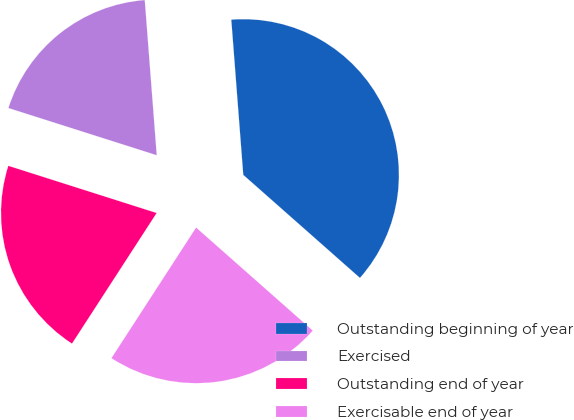Convert chart to OTSL. <chart><loc_0><loc_0><loc_500><loc_500><pie_chart><fcel>Outstanding beginning of year<fcel>Exercised<fcel>Outstanding end of year<fcel>Exercisable end of year<nl><fcel>37.74%<fcel>18.87%<fcel>20.75%<fcel>22.64%<nl></chart> 